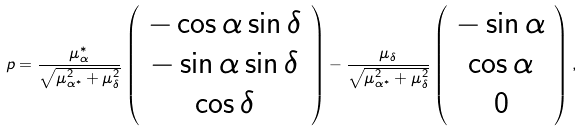Convert formula to latex. <formula><loc_0><loc_0><loc_500><loc_500>p = \frac { \mu _ { \alpha } ^ { * } } { \sqrt { \mu _ { \alpha ^ { * } } ^ { 2 } + \mu _ { \delta } ^ { 2 } } } \left ( \begin{array} { c } - \cos \alpha \sin \delta \\ - \sin \alpha \sin \delta \\ \cos \delta \\ \end{array} \right ) - \frac { \mu _ { \delta } } { \sqrt { \mu _ { \alpha ^ { * } } ^ { 2 } + \mu _ { \delta } ^ { 2 } } } \left ( \begin{array} { c } - \sin \alpha \\ \cos \alpha \\ 0 \\ \end{array} \right ) ,</formula> 